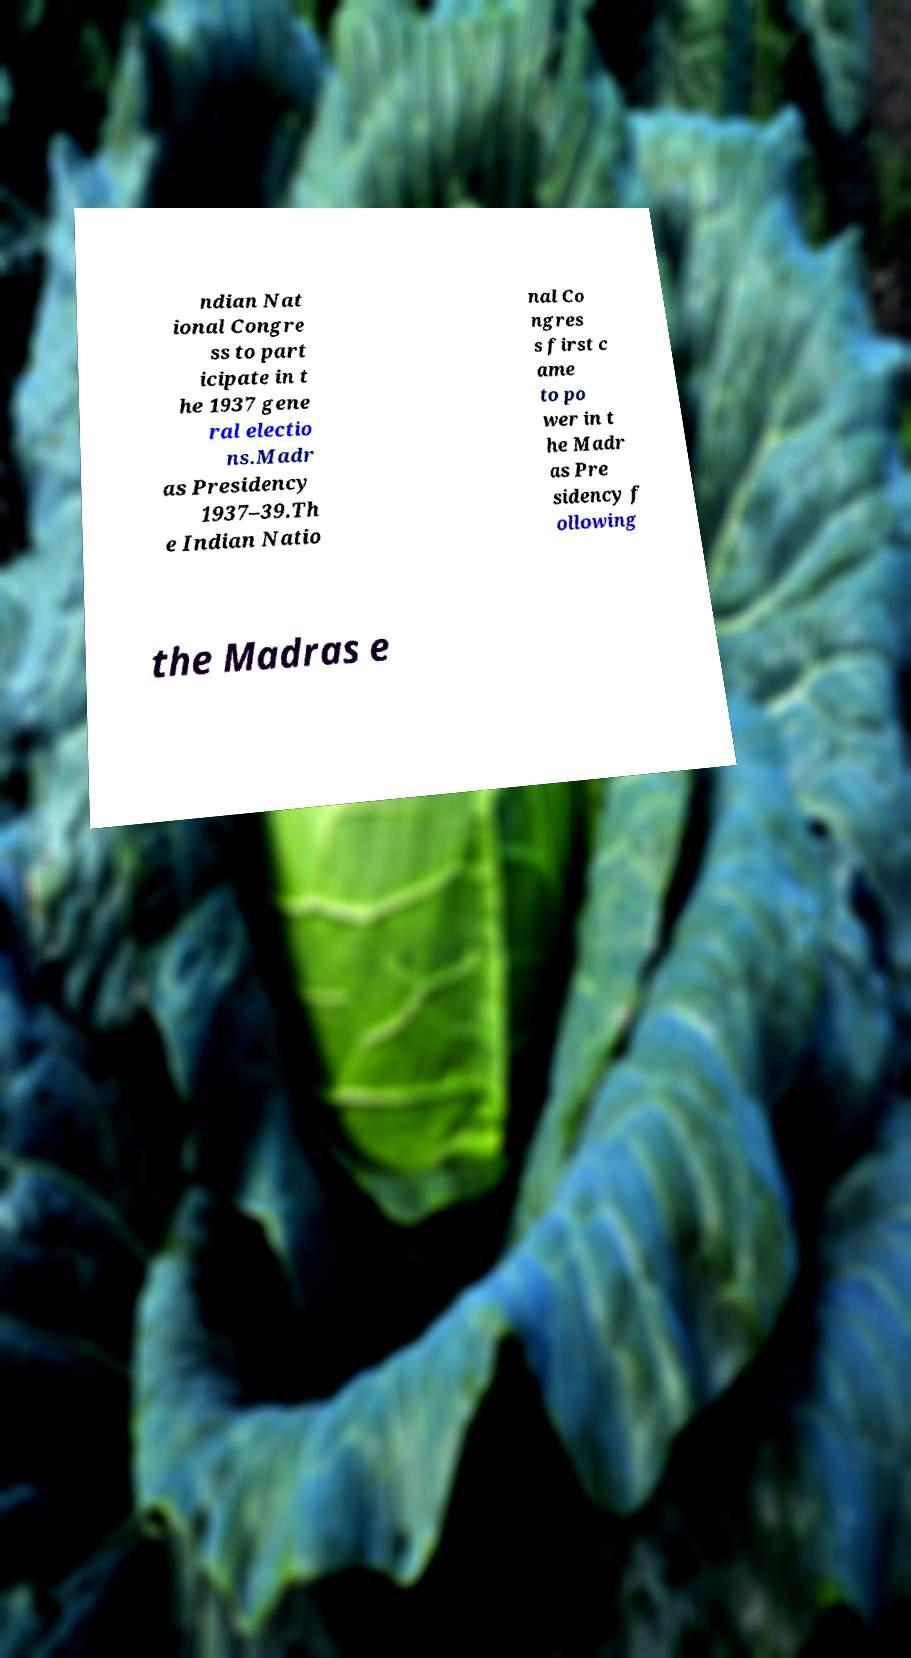Can you accurately transcribe the text from the provided image for me? ndian Nat ional Congre ss to part icipate in t he 1937 gene ral electio ns.Madr as Presidency 1937–39.Th e Indian Natio nal Co ngres s first c ame to po wer in t he Madr as Pre sidency f ollowing the Madras e 